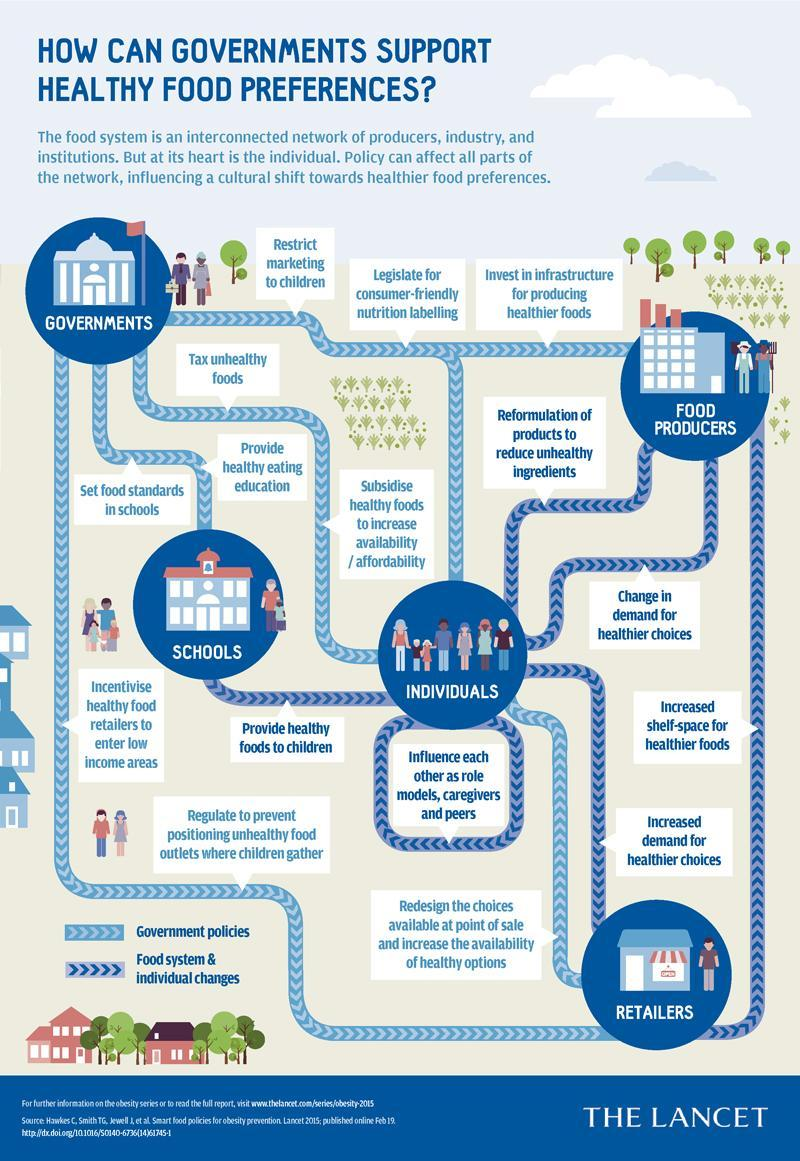Who can set food standards in schools?
Answer the question with a short phrase. Governments How can individuals influence retailers to promote healthy eating? increased demand for healthier choices Who can impose a tax on unhealthy foods? governments What change can be made by retailers to promote healthy eating? increased shelf-space for healthier foods What change can be made by schools to promote healthier eating? provide healthy foods to children Whom does governments ask to provide healthy eating education? schools Who should redesign the food choices placed at point of sale? retailers Who can influence each other as role models, caregivers and peers? individuals Who can reformulate products to reduce unhealthy ingredients? food producers What can be done by government to improve people's access to healthy food? Subsidise healthy foods 